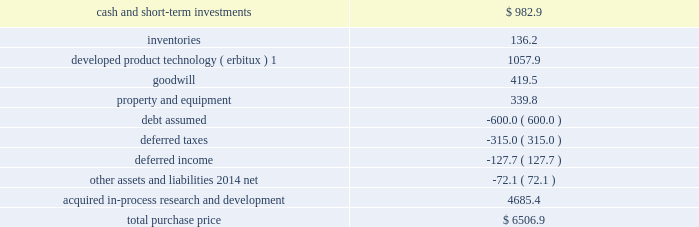For marketing .
There are several methods that can be used to determine the estimated fair value of the ipr&d acquired in a business combination .
We utilized the 201cincome method , 201d which applies a probability weighting to the estimated future net cash fl ows that are derived from projected sales revenues and estimated costs .
These projec- tions are based on factors such as relevant market size , patent protection , historical pricing of similar products , and expected industry trends .
The estimated future net cash fl ows are then discounted to the present value using an appropriate discount rate .
This analysis is performed for each project independently .
In accordance with fin 4 , applicability of fasb statement no .
2 to business combinations accounted for by the purchase method , these acquired ipr&d intangible assets totaling $ 4.71 billion and $ 340.5 million in 2008 and 2007 , respectively , were expensed immediately subsequent to the acquisition because the products had no alternative future use .
The ongoing activities with respect to each of these products in development are not material to our research and development expenses .
In addition to the acquisitions of businesses , we also acquired several products in development .
The acquired ipr&d related to these products of $ 122.0 million and $ 405.1 million in 2008 and 2007 , respectively , was also writ- ten off by a charge to income immediately upon acquisition because the products had no alternative future use .
Imclone acquisition on november 24 , 2008 , we acquired all of the outstanding shares of imclone systems inc .
( imclone ) , a biopharma- ceutical company focused on advancing oncology care , for a total purchase price of approximately $ 6.5 billion , which was fi nanced through borrowings .
This strategic combination will offer both targeted therapies and oncolytic agents along with a pipeline spanning all phases of clinical development .
The combination also expands our bio- technology capabilities .
The acquisition has been accounted for as a business combination under the purchase method of accounting , resulting in goodwill of $ 419.5 million .
No portion of this goodwill is expected to be deductible for tax purposes .
Allocation of purchase price we are currently determining the fair values of a signifi cant portion of these net assets .
The purchase price has been preliminarily allocated based on an estimate of the fair value of assets acquired and liabilities assumed as of the date of acquisition .
The fi nal determination of these fair values will be completed as soon as possible but no later than one year from the acquisition date .
Although the fi nal determination may result in asset and liability fair values that are different than the preliminary estimates of these amounts included herein , it is not expected that those differences will be material to our fi nancial results .
Estimated fair value at november 24 , 2008 .
1this intangible asset will be amortized on a straight-line basis through 2023 in the u.s .
And 2018 in the rest of the world .
All of the estimated fair value of the acquired ipr&d is attributable to oncology-related products in develop- ment , including $ 1.33 billion to line extensions for erbitux .
A signifi cant portion ( 81 percent ) of the remaining value of acquired ipr&d is attributable to two compounds in phase iii clinical testing and one compound in phase ii clini- cal testing , all targeted to treat various forms of cancers .
The discount rate we used in valuing the acquired ipr&d projects was 13.5 percent , and the charge for acquired ipr&d of $ 4.69 billion recorded in the fourth quarter of 2008 , was not deductible for tax purposes .
Pro forma financial information the following unaudited pro forma fi nancial information presents the combined results of our operations with .
What portion of the imclone's total purchase price is dedicated to goodwill? 
Computations: (419.5 / 6506.9)
Answer: 0.06447. 